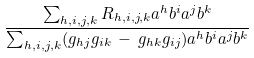Convert formula to latex. <formula><loc_0><loc_0><loc_500><loc_500>\frac { \sum _ { h , i , j , k } R _ { h , i , j , k } a ^ { h } b ^ { i } a ^ { j } b ^ { k } } { \sum _ { h , i , j , k } ( g _ { h j } g _ { i k } \, - \, g _ { h k } g _ { i j } ) a ^ { h } b ^ { i } a ^ { j } b ^ { k } }</formula> 